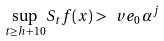Convert formula to latex. <formula><loc_0><loc_0><loc_500><loc_500>\sup _ { t \geq h + 1 0 } S _ { t } f ( x ) > \ v e _ { 0 } \, \alpha ^ { j }</formula> 